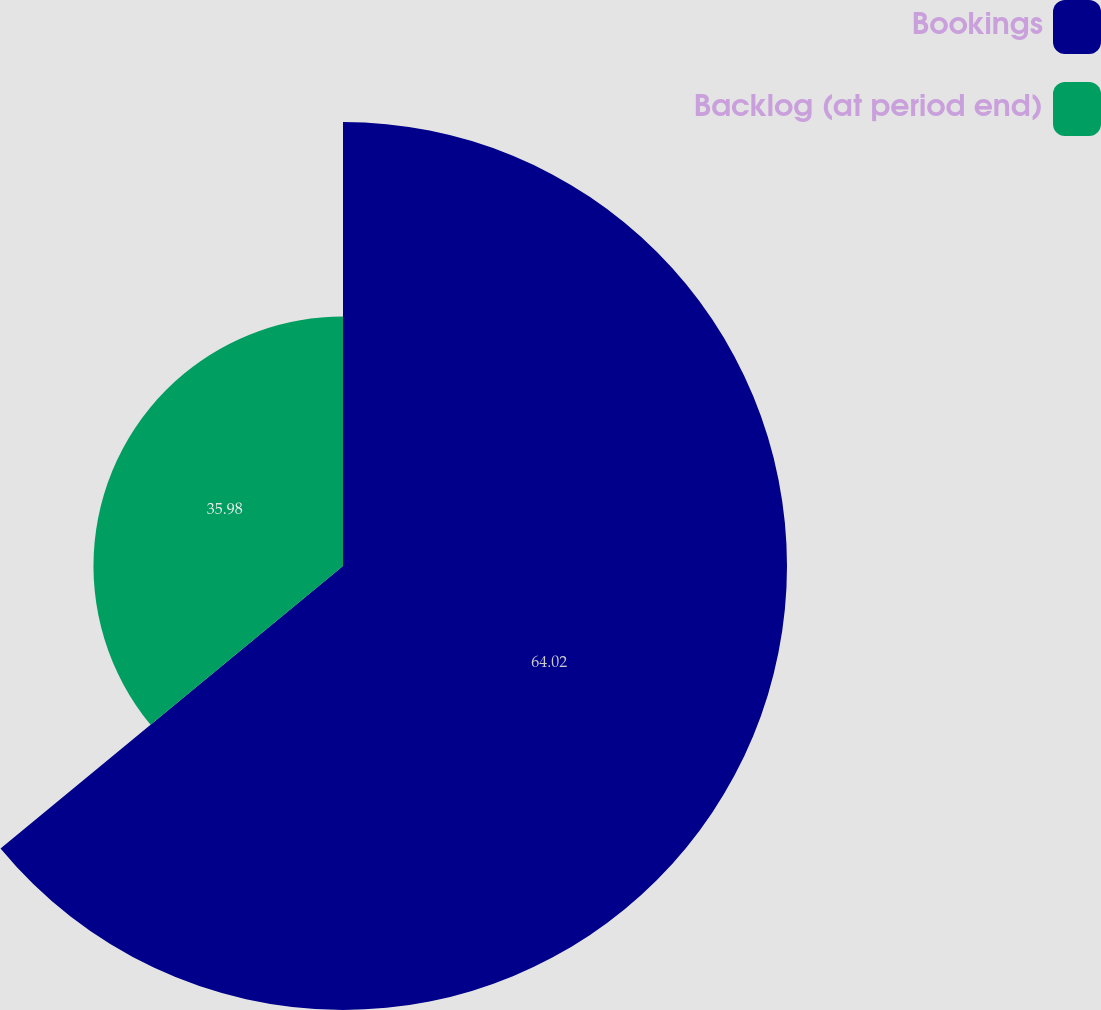Convert chart. <chart><loc_0><loc_0><loc_500><loc_500><pie_chart><fcel>Bookings<fcel>Backlog (at period end)<nl><fcel>64.02%<fcel>35.98%<nl></chart> 